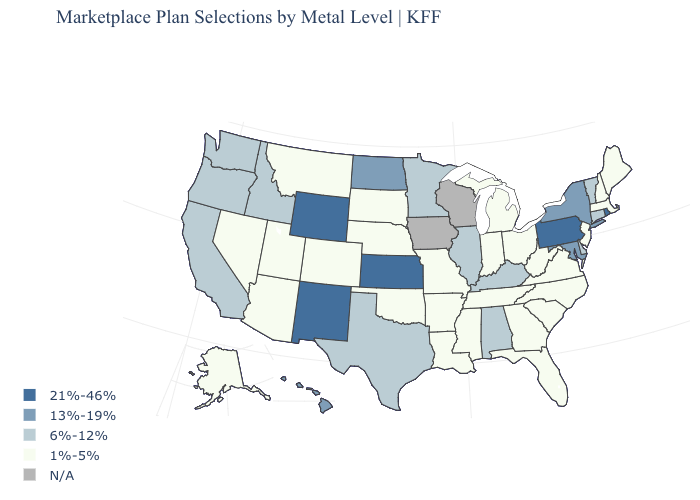Which states hav the highest value in the West?
Keep it brief. New Mexico, Wyoming. Does the map have missing data?
Short answer required. Yes. Name the states that have a value in the range N/A?
Answer briefly. Iowa, Wisconsin. Does the first symbol in the legend represent the smallest category?
Concise answer only. No. Does the first symbol in the legend represent the smallest category?
Give a very brief answer. No. Does the map have missing data?
Be succinct. Yes. Among the states that border Idaho , which have the highest value?
Write a very short answer. Wyoming. Name the states that have a value in the range 6%-12%?
Concise answer only. Alabama, California, Connecticut, Delaware, Idaho, Illinois, Kentucky, Minnesota, Oregon, Texas, Vermont, Washington. What is the value of Washington?
Concise answer only. 6%-12%. Name the states that have a value in the range N/A?
Be succinct. Iowa, Wisconsin. What is the highest value in the West ?
Give a very brief answer. 21%-46%. What is the value of Texas?
Short answer required. 6%-12%. 